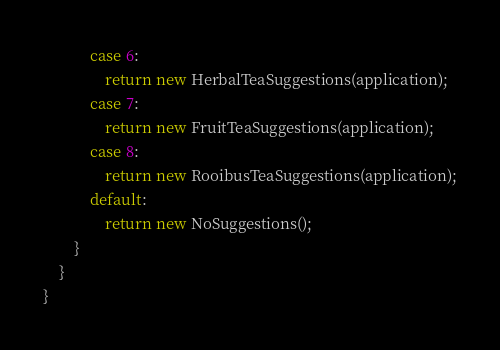Convert code to text. <code><loc_0><loc_0><loc_500><loc_500><_Java_>            case 6:
                return new HerbalTeaSuggestions(application);
            case 7:
                return new FruitTeaSuggestions(application);
            case 8:
                return new RooibusTeaSuggestions(application);
            default:
                return new NoSuggestions();
        }
    }
}
</code> 